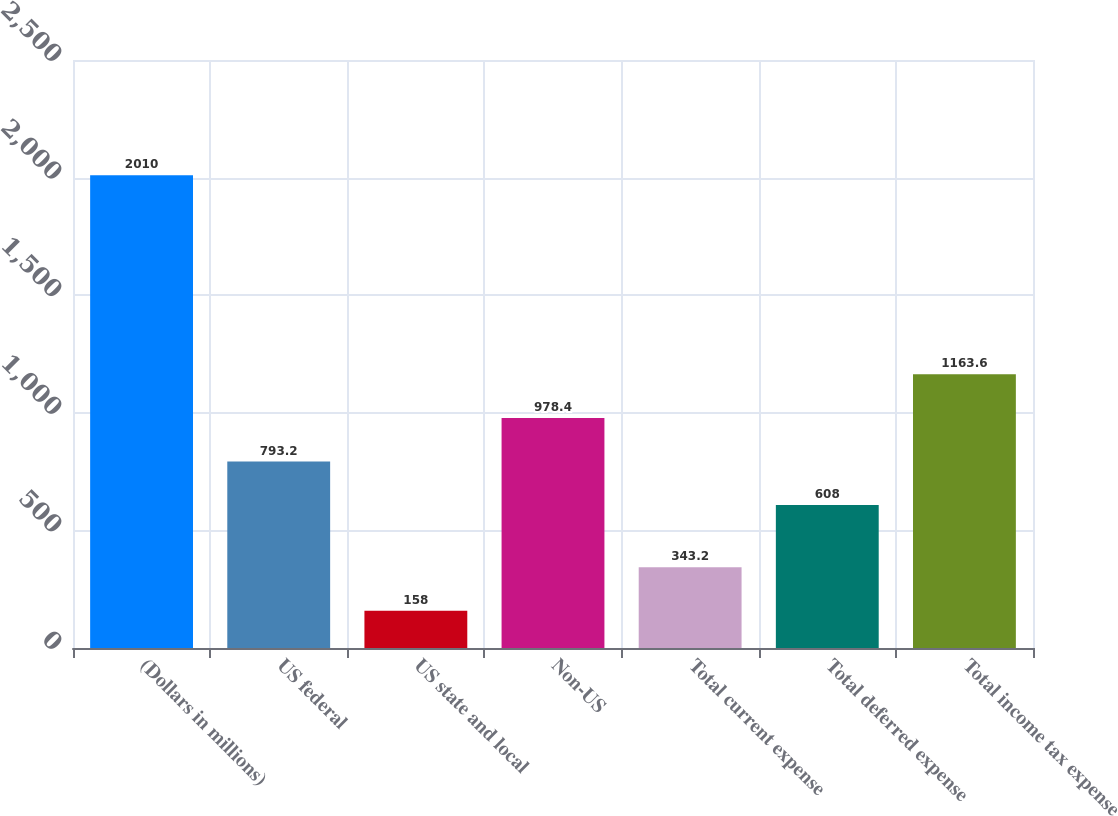<chart> <loc_0><loc_0><loc_500><loc_500><bar_chart><fcel>(Dollars in millions)<fcel>US federal<fcel>US state and local<fcel>Non-US<fcel>Total current expense<fcel>Total deferred expense<fcel>Total income tax expense<nl><fcel>2010<fcel>793.2<fcel>158<fcel>978.4<fcel>343.2<fcel>608<fcel>1163.6<nl></chart> 